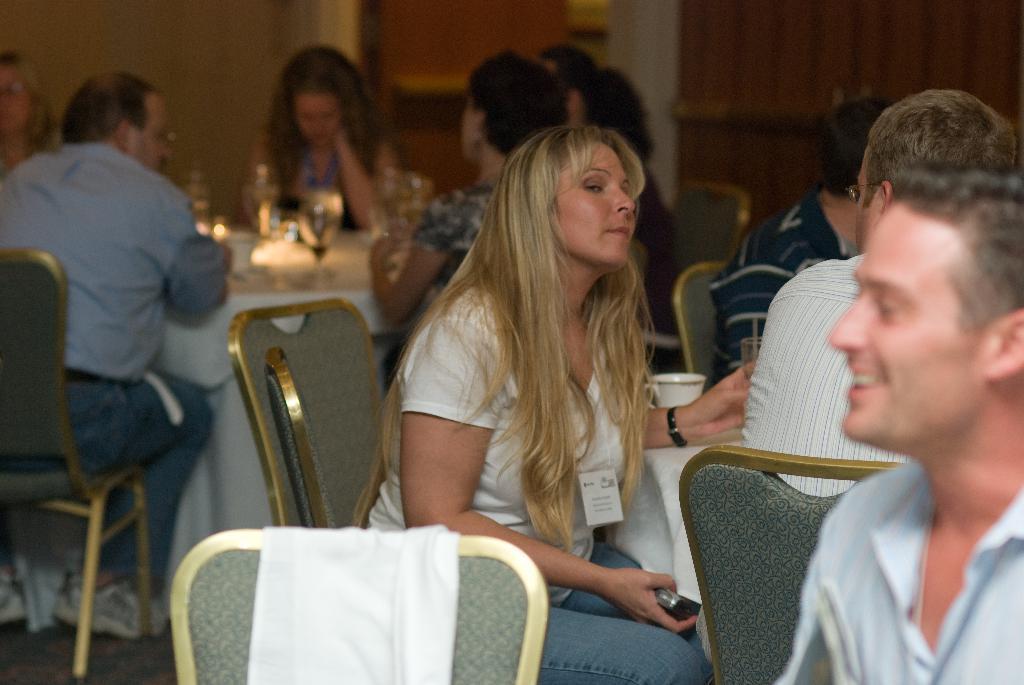In one or two sentences, can you explain what this image depicts? In this picture, we can see a group of people sitting on chairs and in front of the people there are tables and on the tables there is a cup, glasses and other items. Behind the people there is a wall. 